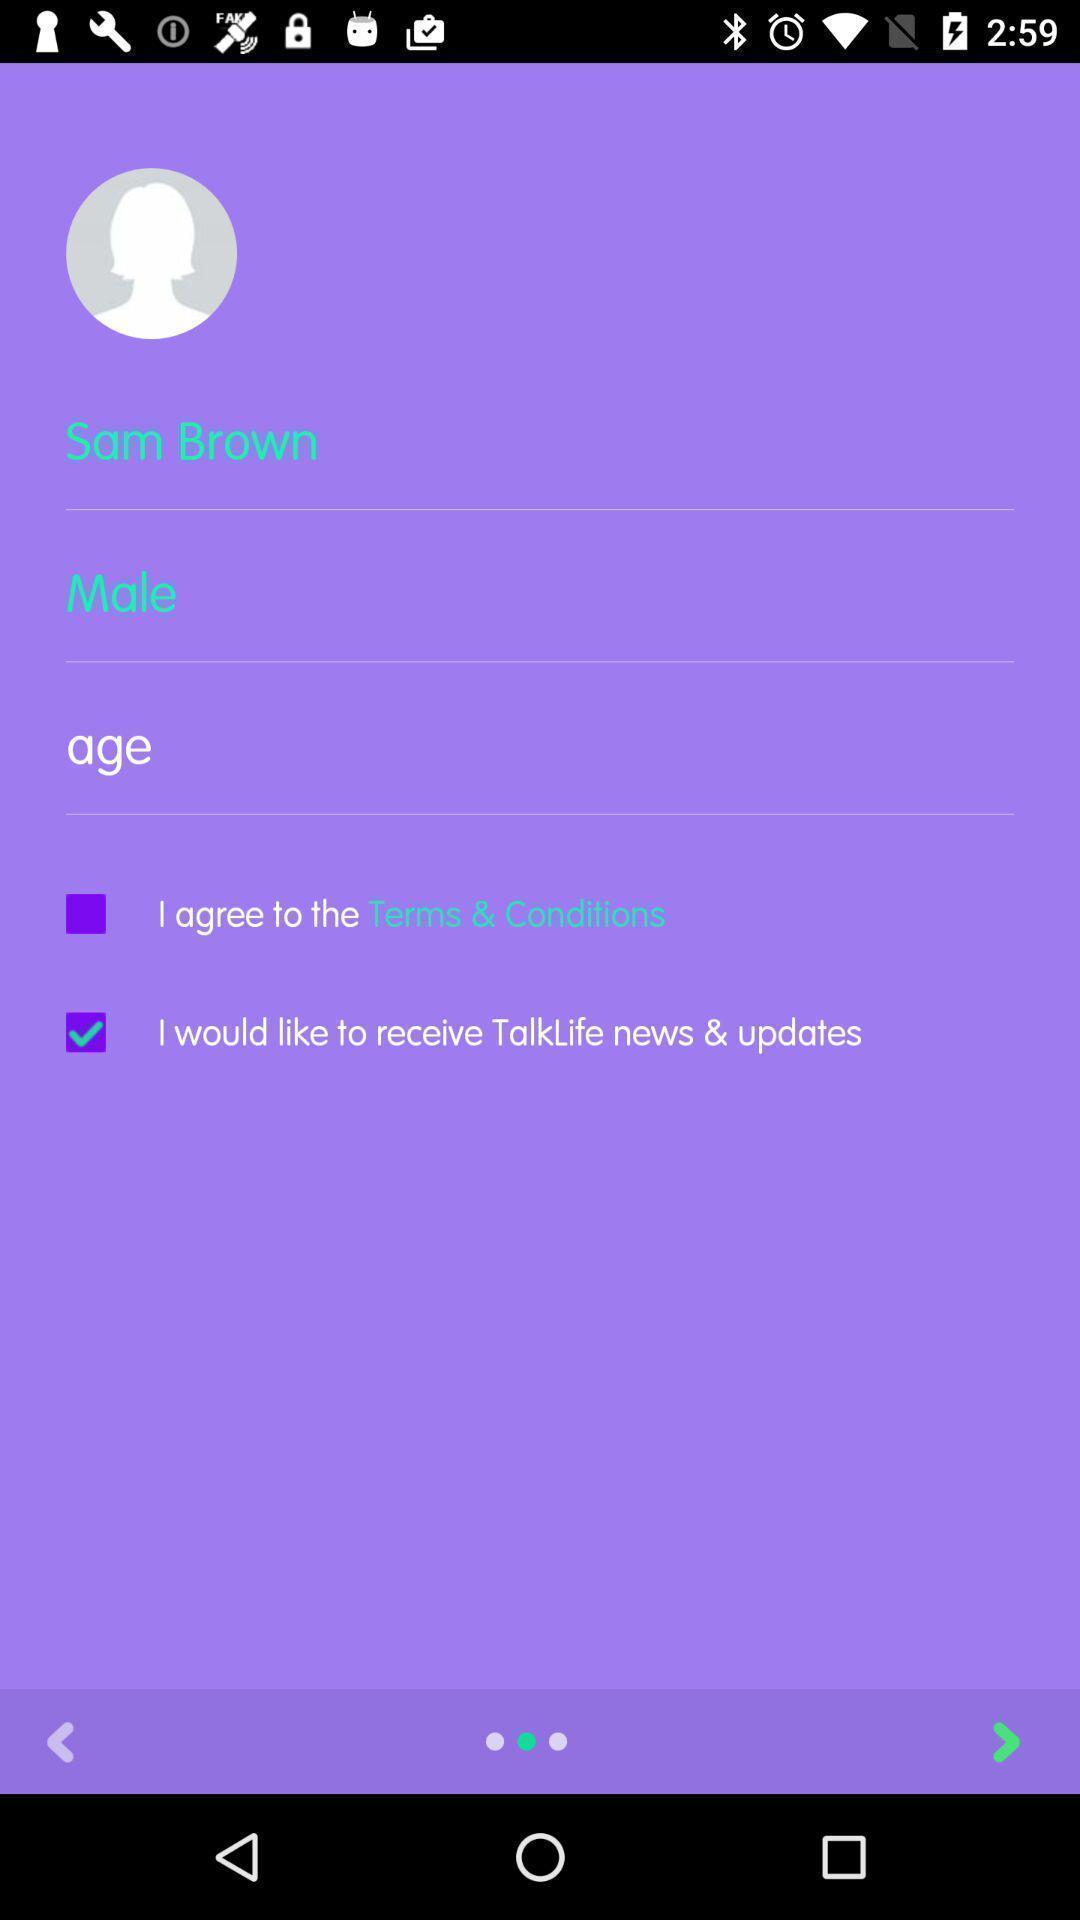Please provide a description for this image. Sign in page. 